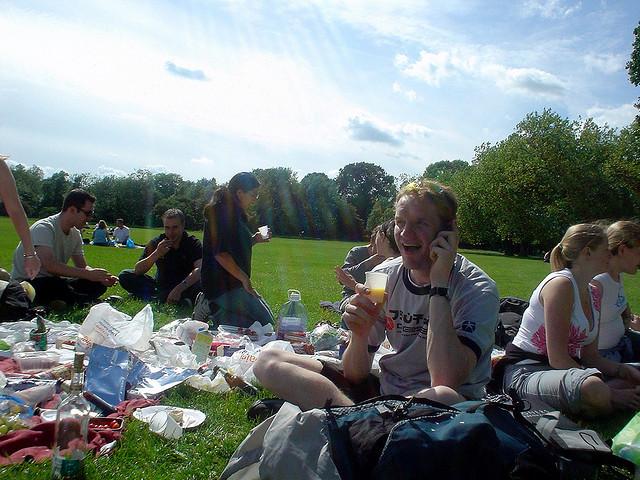Are they standing on grass?
Quick response, please. No. What color is the grass?
Be succinct. Green. How many bags are there?
Write a very short answer. 1. What color is the hat on the man in the foreground?
Be succinct. No hat. What is this person holding?
Keep it brief. Juice. Where is this taken?
Quick response, please. Park. Where is the man sitting?
Short answer required. On grass. 